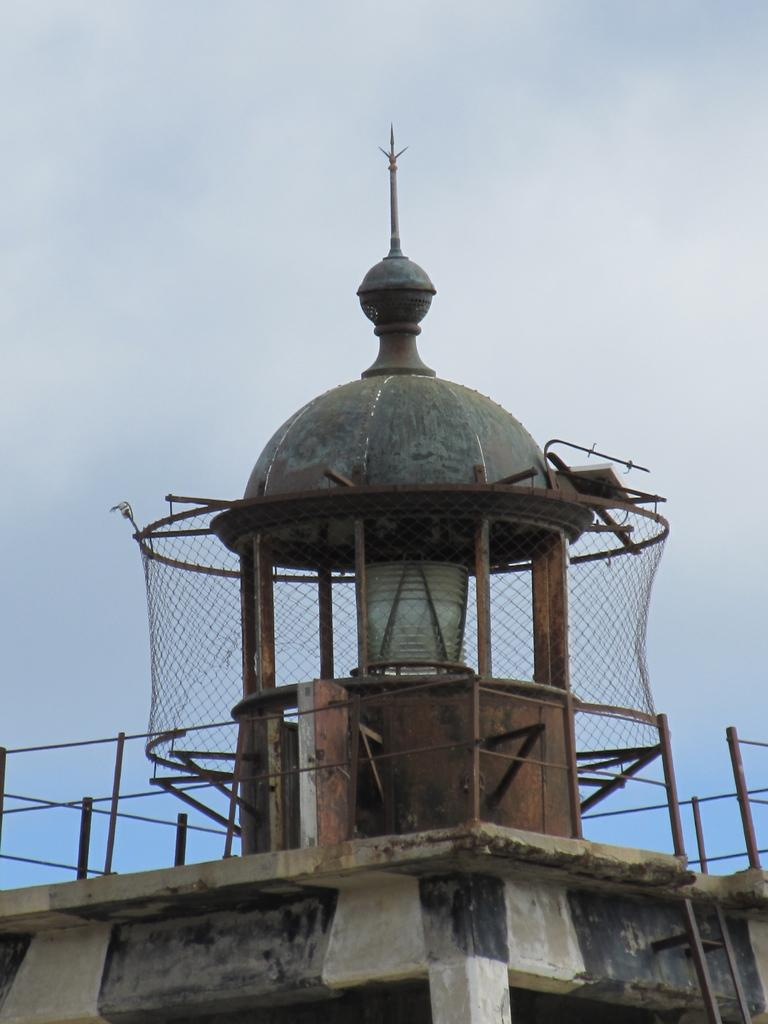What type of structure is on top of the building in the image? There is a small dome tower on the top of the building. Where is the dome tower located on the building? The dome tower is on the building's roof. What is surrounding the dome tower? There is a fencing net around the dome tower. What can be seen in the background of the image? There is a blue sky visible in the background. What type of hook is attached to the dome tower for spotting punishment? There is no hook or mention of punishment in the image; it only features a small dome tower on a building with a fencing net around it and a blue sky in the background. 